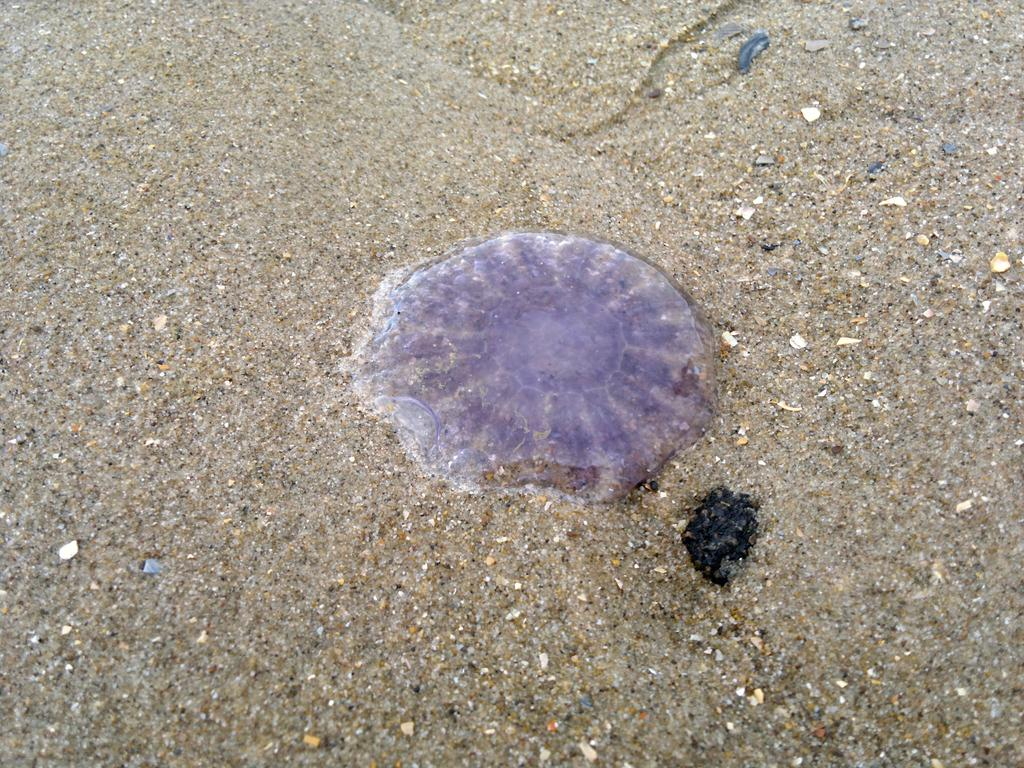What is the main subject in the center of the image? There is a sea shell in the center of the image. What type of surface is the sea shell resting on? The sea shell is on a sand floor. What type of stick can be seen being used to order food in the image? There is no stick or food ordering activity present in the image; it features a sea shell on a sand floor. Can you see a boot in the image? There is no boot present in the image. 